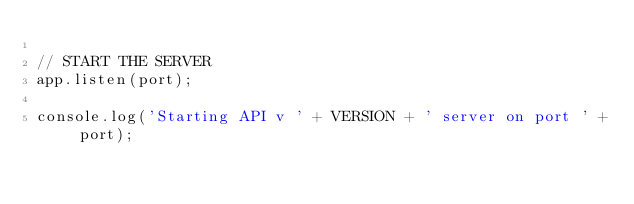<code> <loc_0><loc_0><loc_500><loc_500><_JavaScript_>
// START THE SERVER
app.listen(port);

console.log('Starting API v ' + VERSION + ' server on port ' + port);</code> 